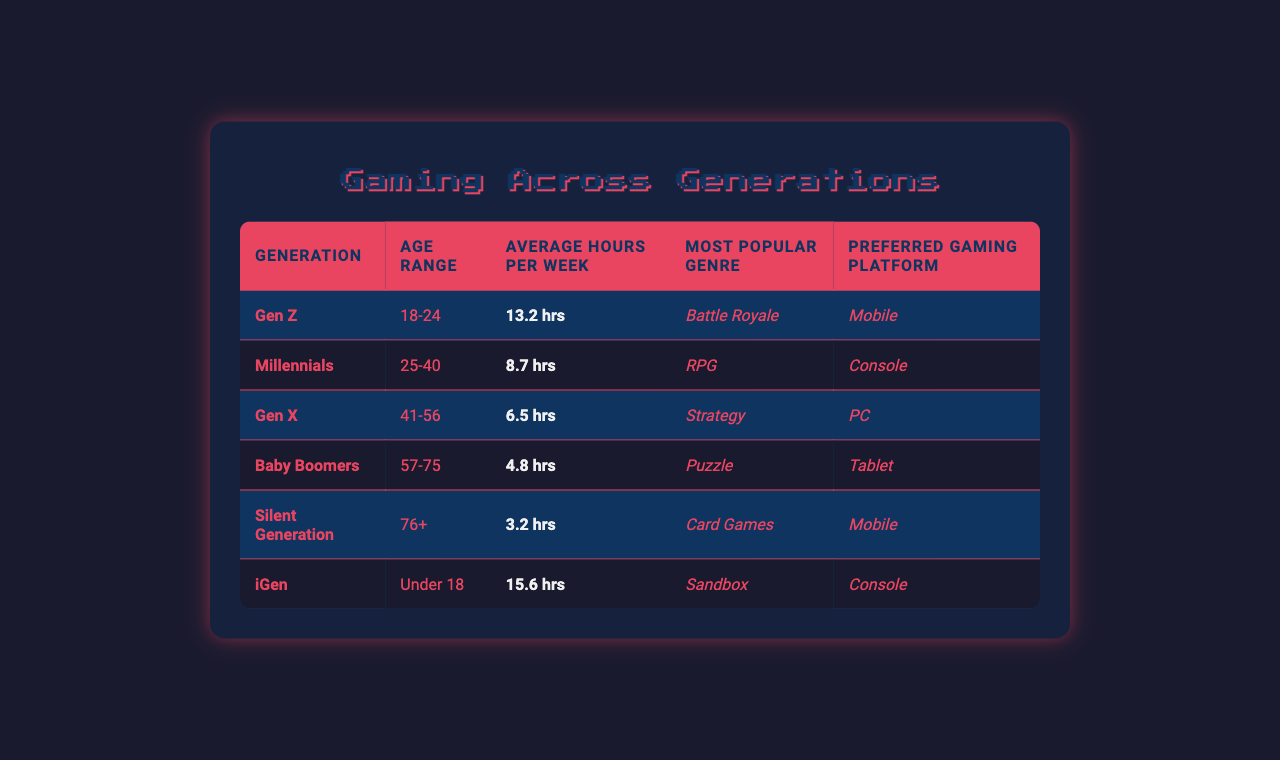What is the average time spent gaming per week by Gen Z? The table shows that Gen Z, who are aged 18-24, spend an average of 13.2 hours per week gaming.
Answer: 13.2 hours Which gaming genre is most popular among Millennials? According to the table, Millennials (aged 25-40) prefer RPGs as their most popular gaming genre.
Answer: RPG How many hours do Baby Boomers spend gaming on average compared to Gen X? Baby Boomers spend an average of 4.8 hours per week, whereas Gen X spends 6.5 hours. The difference in hours is 6.5 - 4.8 = 1.7 hours.
Answer: 1.7 hours Is the most popular gaming platform for the Silent Generation mobile? Yes, the table indicates that the preferred platform for the Silent Generation (aged 76+) is mobile.
Answer: Yes What is the average time spent gaming per week for the two youngest generations (iGen and Gen Z)? For iGen (under 18), the average is 15.6 hours, and for Gen Z, it is 13.2 hours. The average time spent for both is (15.6 + 13.2) / 2 = 14.4 hours.
Answer: 14.4 hours Which generation has the lowest average gaming time per week? From the table, the Silent Generation (76+) has the lowest average gaming time at 3.2 hours per week.
Answer: Silent Generation How does the average gaming time of the iGen compare to that of Baby Boomers? iGen spends an average of 15.6 hours, while Baby Boomers spend 4.8 hours. The comparison reveals a difference of 15.6 - 4.8 = 10.8 hours, indicating iGen games significantly more.
Answer: 10.8 hours What is the total average gaming time per week of all generations combined? Adding the average hours: 13.2 (Gen Z) + 8.7 (Millennials) + 6.5 (Gen X) + 4.8 (Baby Boomers) + 3.2 (Silent Generation) + 15.6 (iGen) gives a total of 52 hours. This total divided by the number of generations (6) yields an average of 52 / 6 = 8.67 hours.
Answer: 8.67 hours Is it true that all generations prefer gaming on mobile platforms? No, the table indicates that the preferred platforms vary, with Gen X preferring PC and Millennials favoring console, so not all generations prefer mobile.
Answer: No 